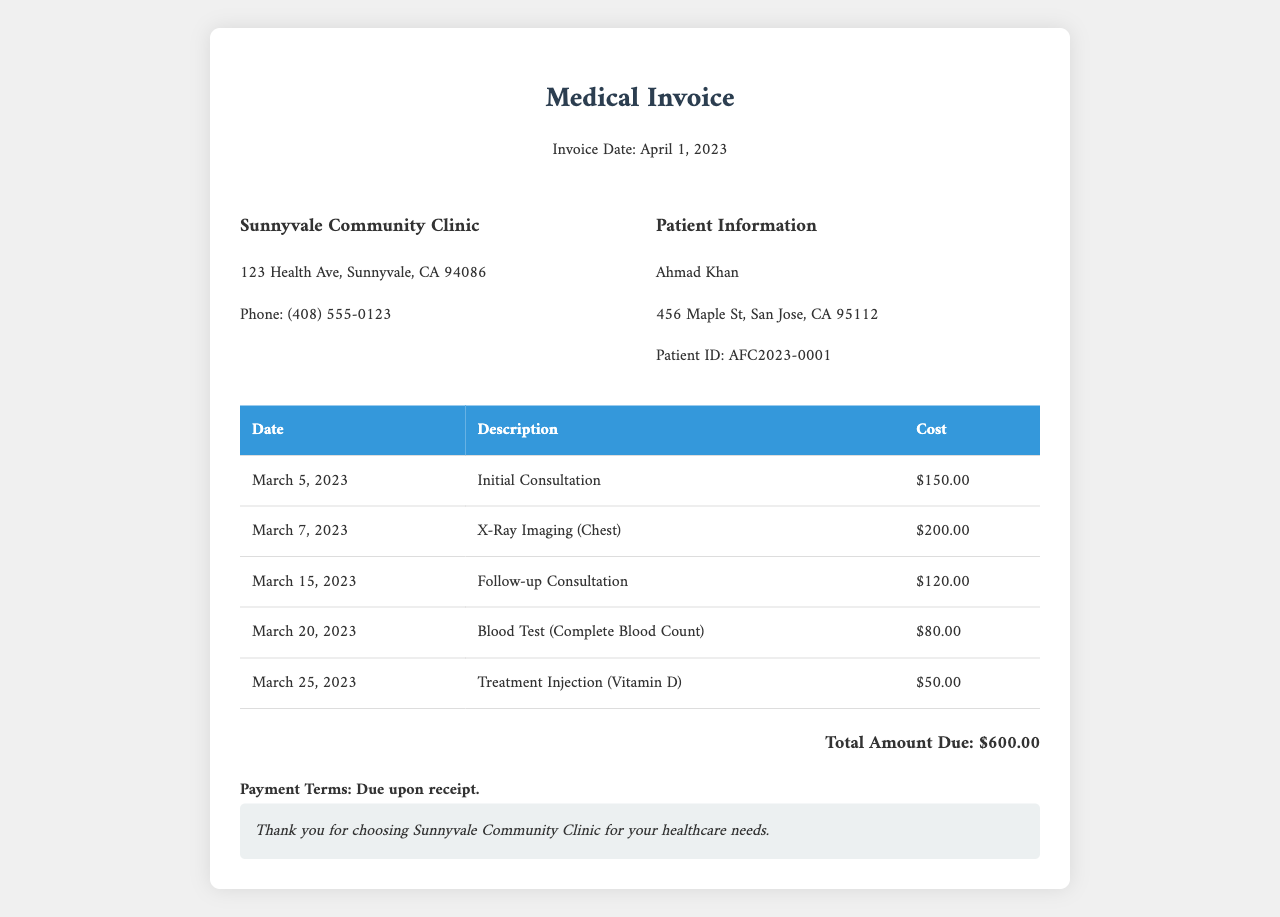What is the invoice date? The invoice date is specifically mentioned at the top of the document.
Answer: April 1, 2023 Who is the patient? The patient information section provides the name of the individual receiving the services.
Answer: Ahmad Khan What is the total amount due? The total amount due appears at the bottom of the document, summarizing the costs of all services.
Answer: $600.00 How many consultations were billed in March 2023? By reviewing the document, we can count the number of consultations listed.
Answer: 2 What type of service was provided on March 7, 2023? The table lists the service corresponding to the specific date.
Answer: X-Ray Imaging (Chest) What is the cost of the Blood Test? The cost associated with the Blood Test is specified in the table of services.
Answer: $80.00 What is the payment term stated in the invoice? The payment terms are explicitly mentioned towards the end of the document.
Answer: Due upon receipt What is the address of the clinic? The address of the clinic is provided in the clinic information section.
Answer: 123 Health Ave, Sunnyvale, CA 94086 